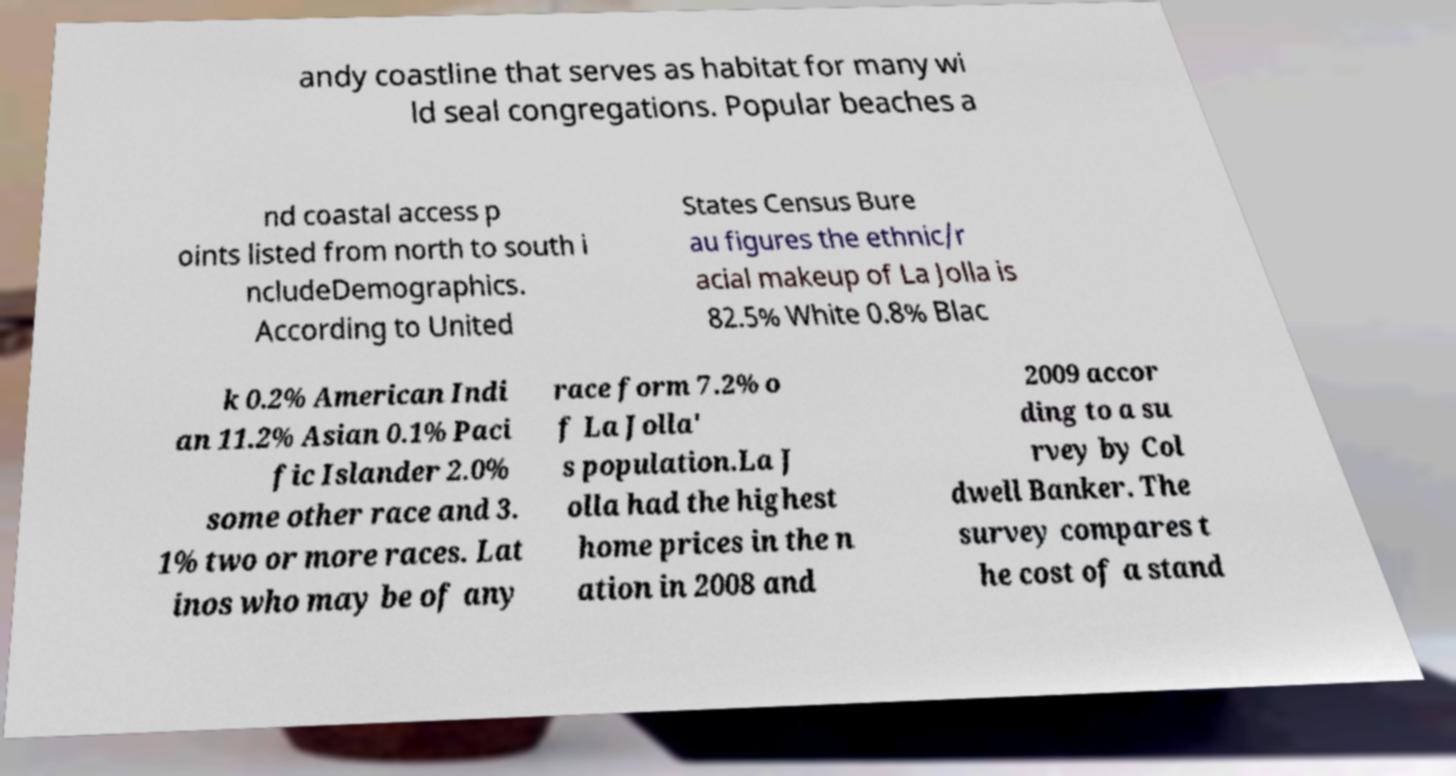Could you extract and type out the text from this image? andy coastline that serves as habitat for many wi ld seal congregations. Popular beaches a nd coastal access p oints listed from north to south i ncludeDemographics. According to United States Census Bure au figures the ethnic/r acial makeup of La Jolla is 82.5% White 0.8% Blac k 0.2% American Indi an 11.2% Asian 0.1% Paci fic Islander 2.0% some other race and 3. 1% two or more races. Lat inos who may be of any race form 7.2% o f La Jolla' s population.La J olla had the highest home prices in the n ation in 2008 and 2009 accor ding to a su rvey by Col dwell Banker. The survey compares t he cost of a stand 